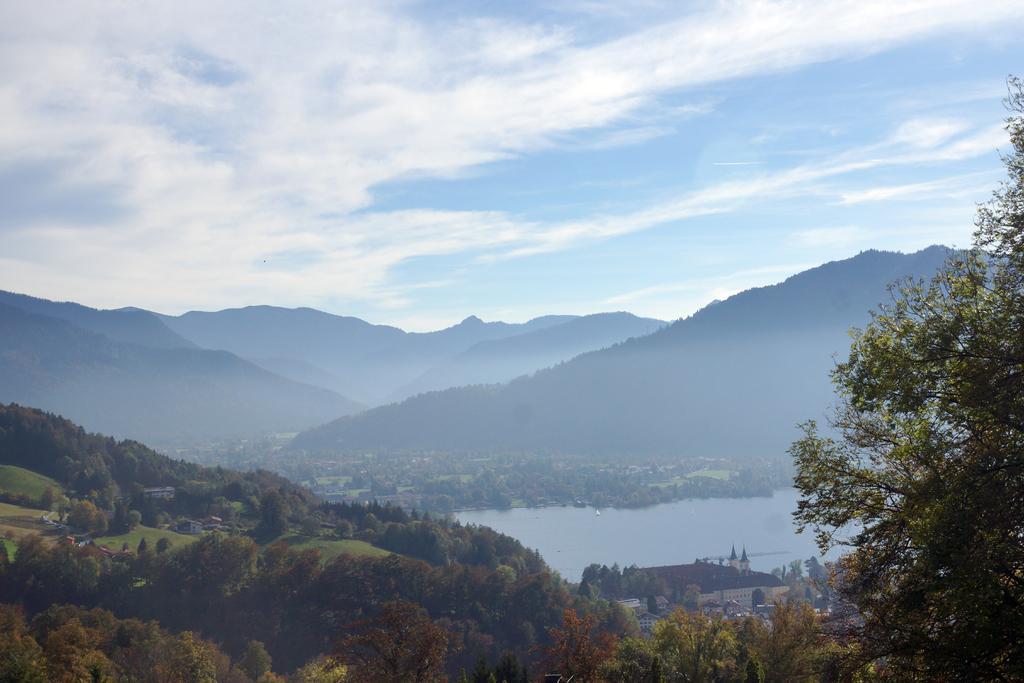How would you summarize this image in a sentence or two? In this picture I can see trees, houses, water, hills, and in the background there is sky. 